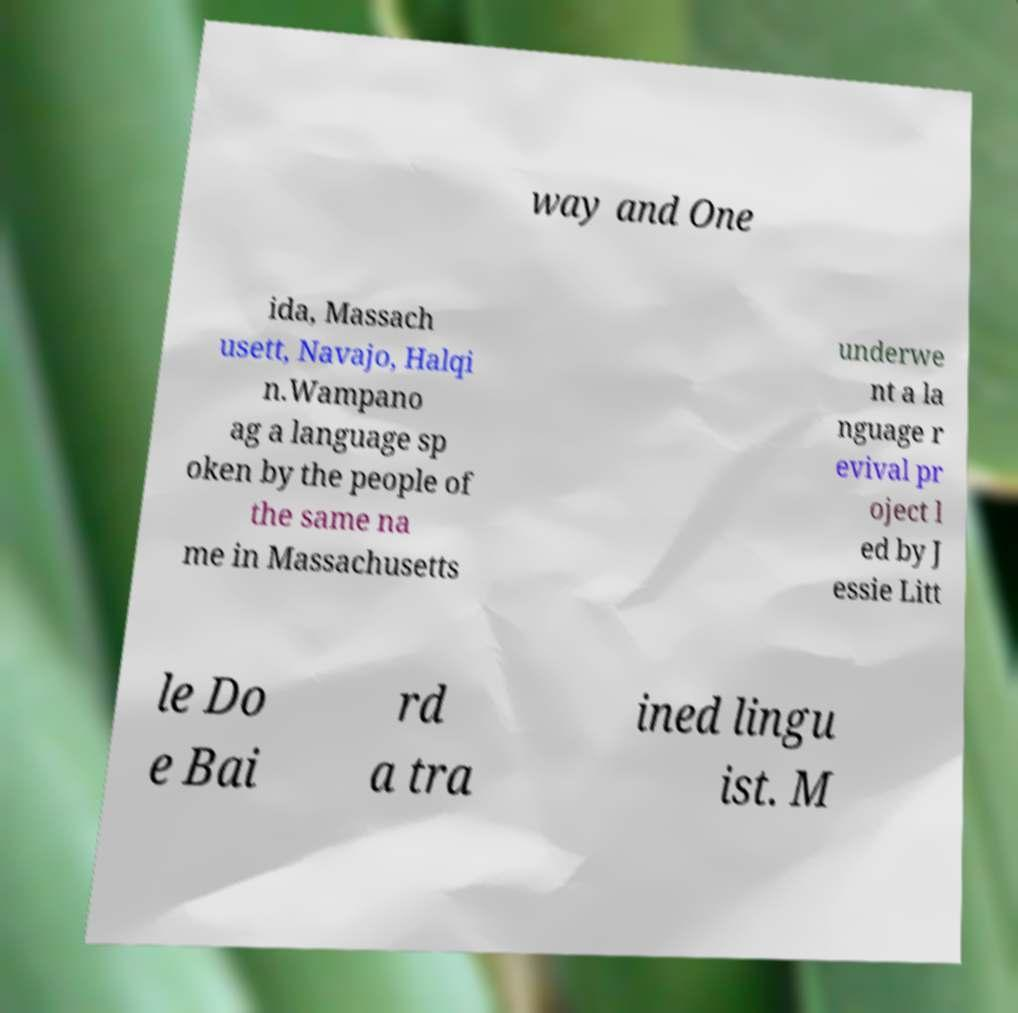There's text embedded in this image that I need extracted. Can you transcribe it verbatim? way and One ida, Massach usett, Navajo, Halqi n.Wampano ag a language sp oken by the people of the same na me in Massachusetts underwe nt a la nguage r evival pr oject l ed by J essie Litt le Do e Bai rd a tra ined lingu ist. M 